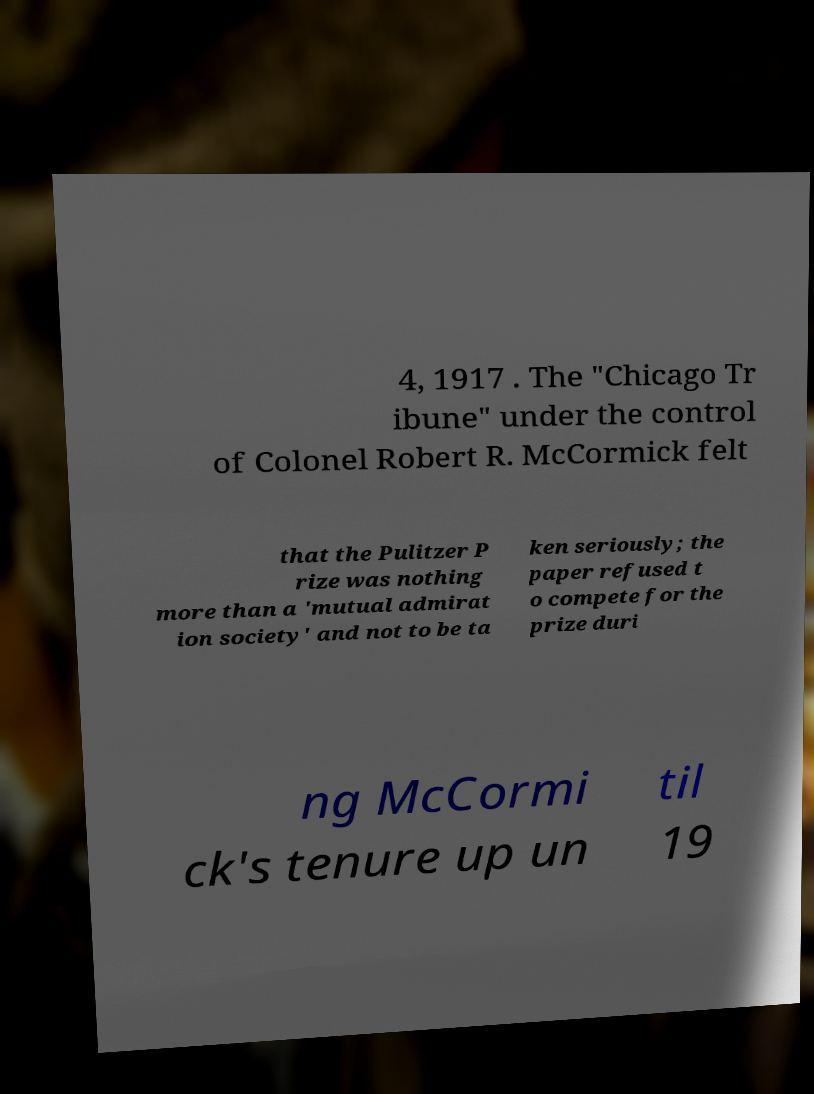There's text embedded in this image that I need extracted. Can you transcribe it verbatim? 4, 1917 . The "Chicago Tr ibune" under the control of Colonel Robert R. McCormick felt that the Pulitzer P rize was nothing more than a 'mutual admirat ion society' and not to be ta ken seriously; the paper refused t o compete for the prize duri ng McCormi ck's tenure up un til 19 